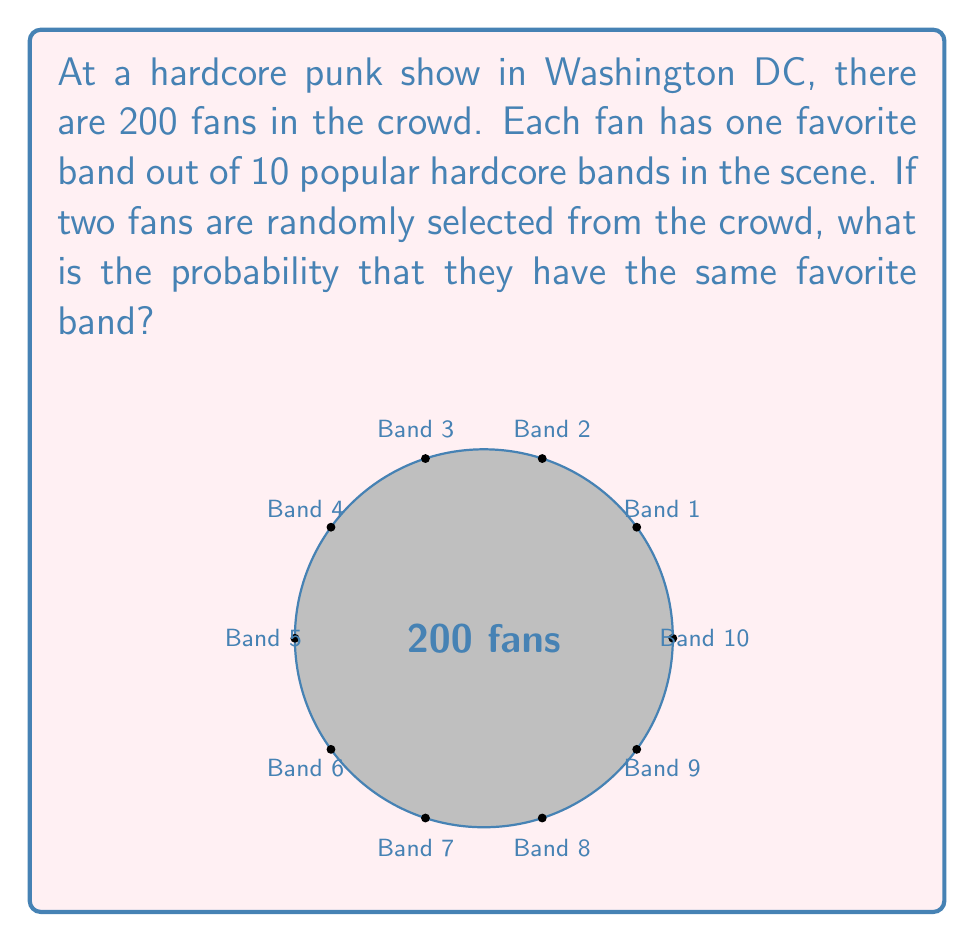Provide a solution to this math problem. Let's approach this step-by-step:

1) First, we need to understand what we're calculating. We want the probability that two randomly selected fans have the same favorite band.

2) We can use the concept of conditional probability here. Let's break it down:
   - The probability of the first fan having any particular favorite band is 1/10.
   - Given that the first fan has chosen a band, the probability of the second fan choosing the same band is 19/199 (as there are 19 other fans out of the remaining 199 who like that band).

3) Let's calculate:
   
   $$P(\text{same band}) = P(\text{first fan's choice}) \times P(\text{second fan matches | first fan's choice})$$
   
   $$P(\text{same band}) = 1 \times \frac{19}{199} = \frac{19}{199} = \frac{0.19}{1.99} \approx 0.0955$$

4) However, this is the probability for just one specific band. We need to consider all 10 bands.

5) Since the events of matching on different bands are mutually exclusive (they can't happen simultaneously), we can add these probabilities:

   $$P(\text{same band overall}) = 10 \times \frac{19}{199} = \frac{190}{199} \approx 0.9548$$

6) Therefore, the probability that two randomly selected fans have the same favorite band is approximately 0.9548 or about 95.48%.
Answer: $\frac{190}{199} \approx 0.9548$ 